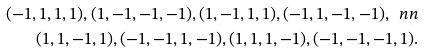Convert formula to latex. <formula><loc_0><loc_0><loc_500><loc_500>( - 1 , 1 , 1 , 1 ) , ( 1 , - 1 , - 1 , - 1 ) , ( 1 , - 1 , 1 , 1 ) , ( - 1 , 1 , - 1 , - 1 ) , \ n n \\ ( 1 , 1 , - 1 , 1 ) , ( - 1 , - 1 , 1 , - 1 ) , ( 1 , 1 , 1 , - 1 ) , ( - 1 , - 1 , - 1 , 1 ) .</formula> 